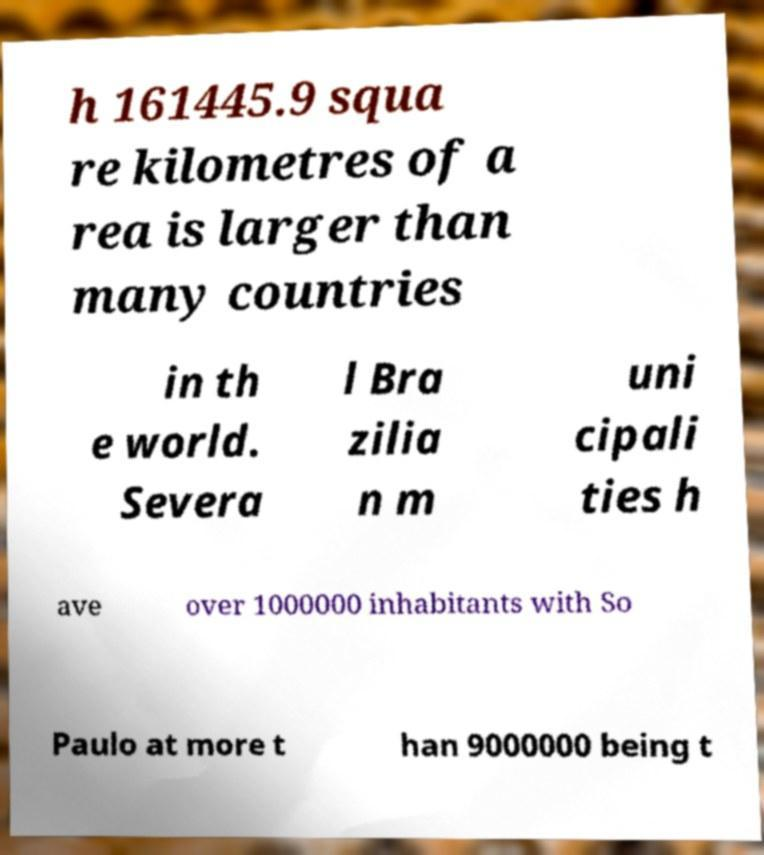Could you extract and type out the text from this image? h 161445.9 squa re kilometres of a rea is larger than many countries in th e world. Severa l Bra zilia n m uni cipali ties h ave over 1000000 inhabitants with So Paulo at more t han 9000000 being t 